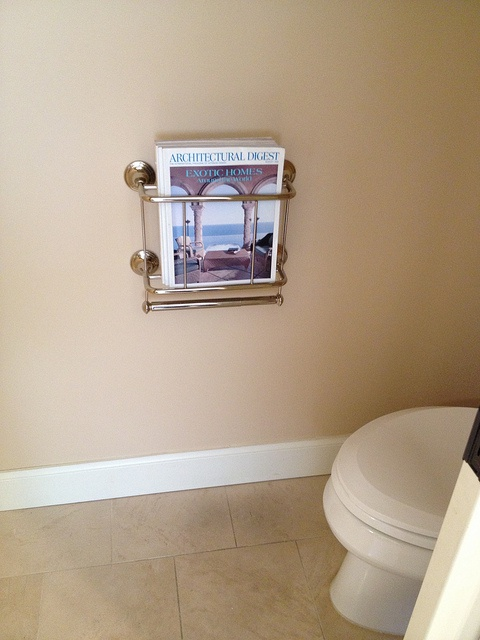Describe the objects in this image and their specific colors. I can see toilet in lightgray, gray, and tan tones and book in lightgray, lavender, darkgray, and purple tones in this image. 